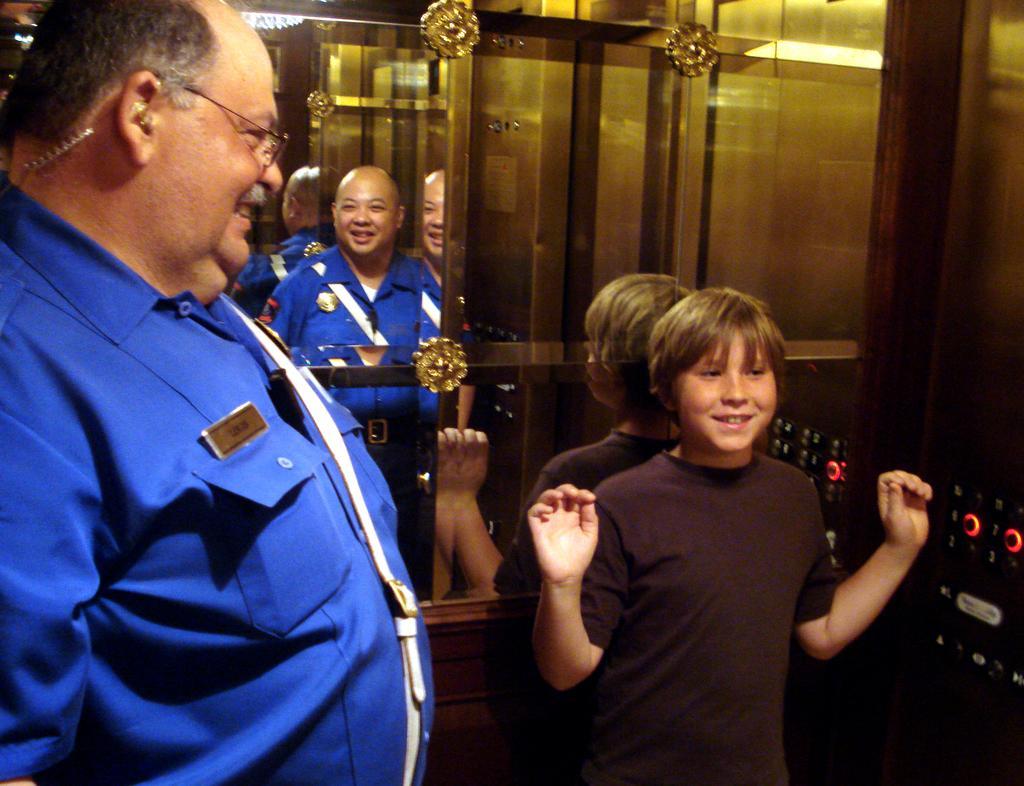How would you summarize this image in a sentence or two? In this picture there is a man who is wearing spectacle and shirt. In front of him there is a boy who is wearing t-shirt and standing near to the lift buttons. In the mirror reflection I can see a bald man who is wearing a blue dress. They are standing in the elevator. 